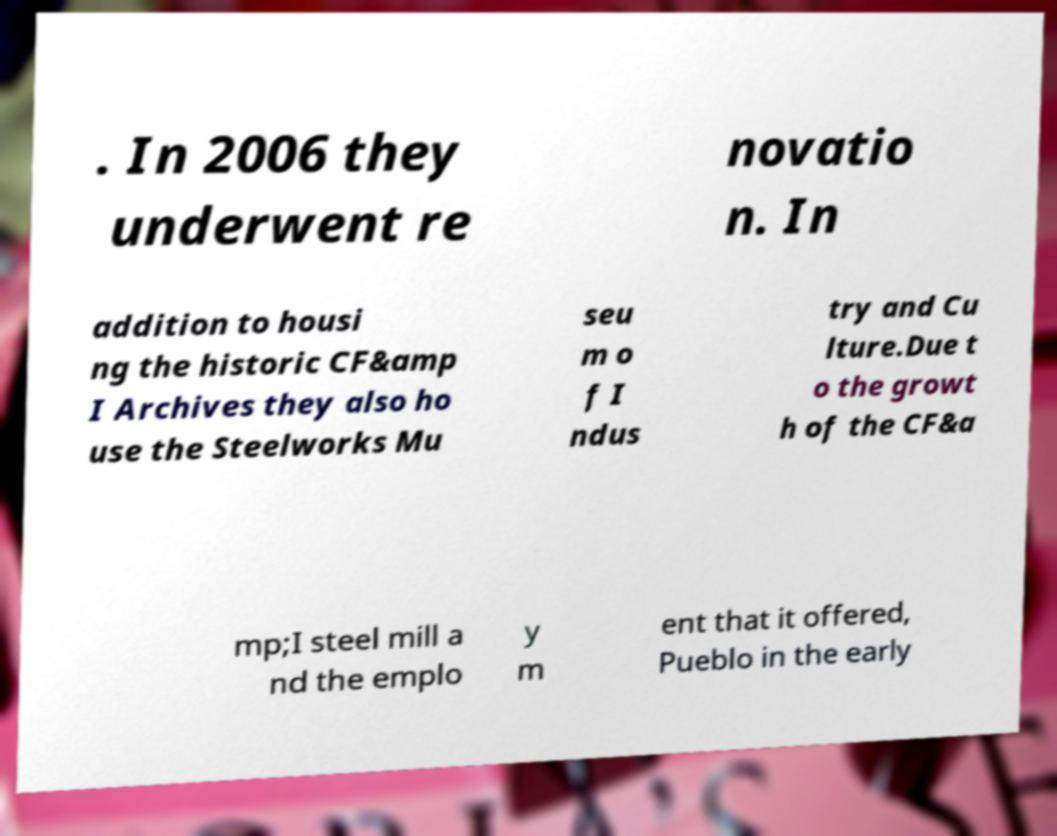Could you extract and type out the text from this image? . In 2006 they underwent re novatio n. In addition to housi ng the historic CF&amp I Archives they also ho use the Steelworks Mu seu m o f I ndus try and Cu lture.Due t o the growt h of the CF&a mp;I steel mill a nd the emplo y m ent that it offered, Pueblo in the early 